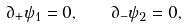<formula> <loc_0><loc_0><loc_500><loc_500>\partial _ { + } \psi _ { 1 } = 0 , \quad \partial _ { - } \psi _ { 2 } = 0 ,</formula> 